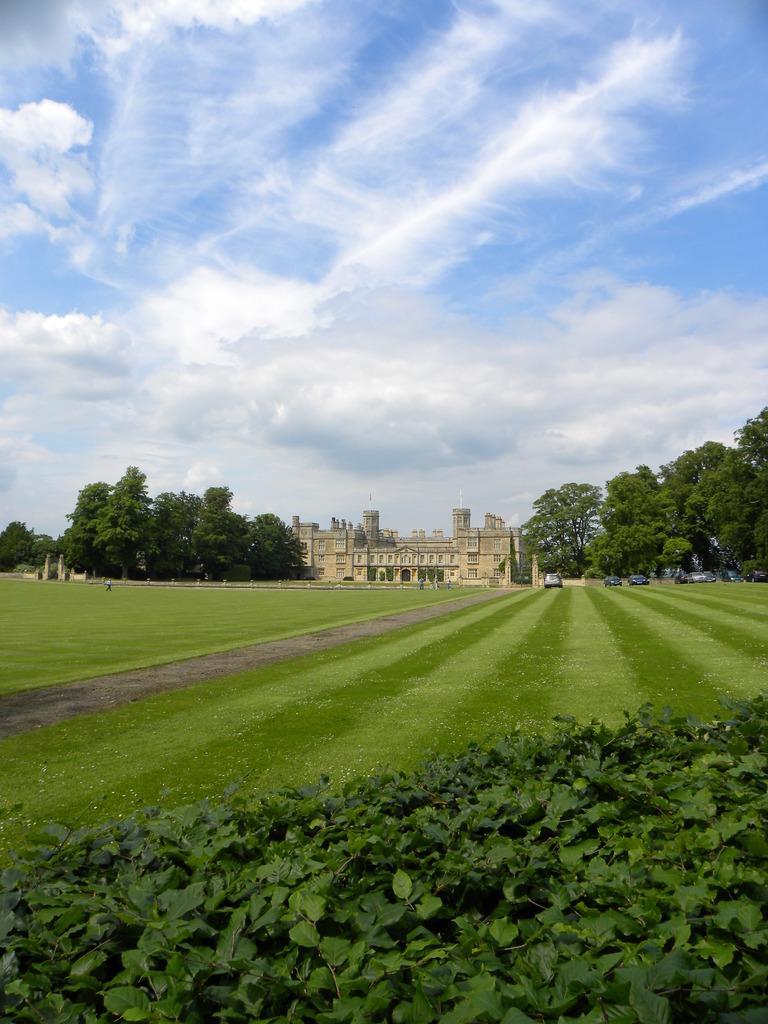Can you describe this image briefly? In the image we can see a building, path, grass, trees and a cloudy sky. We can even see there are vehicles. 